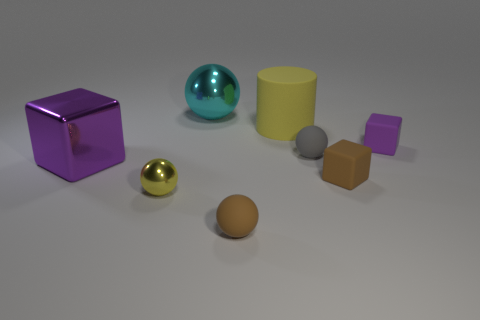How do the different textures of the objects affect the overall aesthetic of the image? The different textures add depth and visual interest to the image. The shiny surfaces of the metallic cube and sphere reflect light and add a sense of luxury or high quality. In contrast, the matte surfaces of the yellow cylinder and the brown sphere absorb light, giving a softer, more understated look. These textural differences create a diverse tactile sensation, implying how the objects might feel if touched, and provide a richer experience for the viewer. 